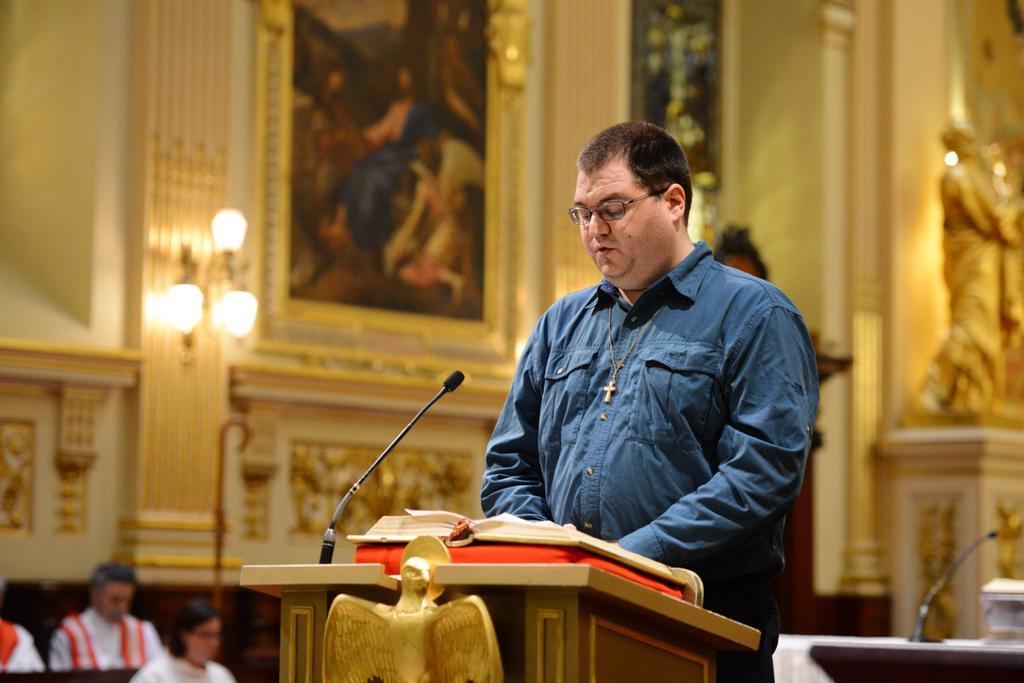Please provide a concise description of this image. In the center of the image a man is standing. At the bottom of the image we can see a podium. On the podium we can see a book, mic are present. At the bottom left corner we can see some person are there. In the background of the image we can see sculpture, frame, lights, wall are present. 